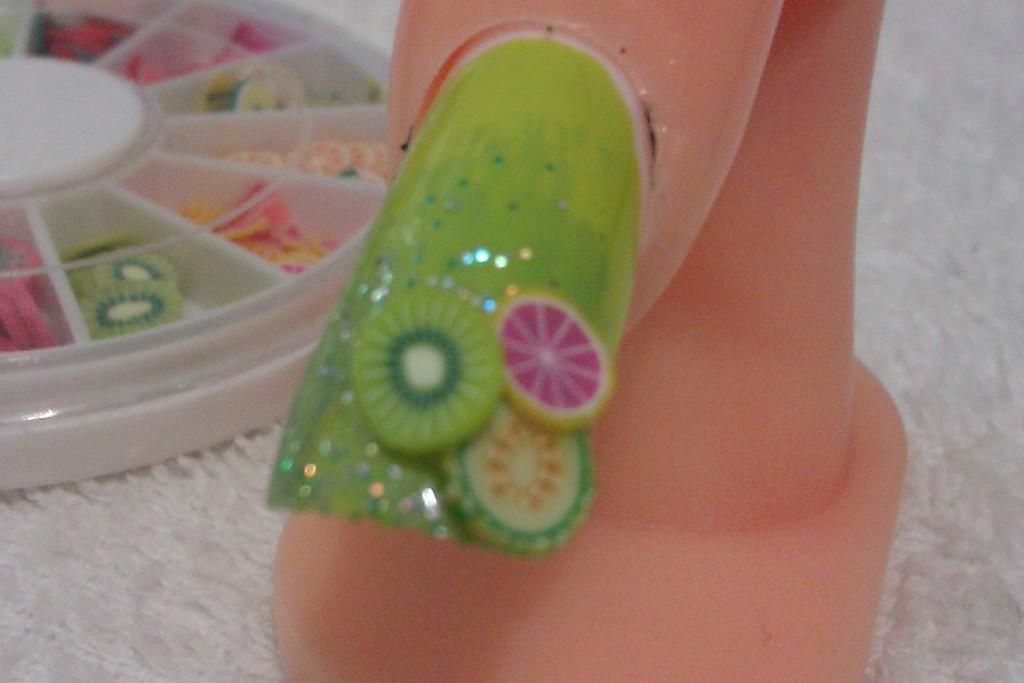What is the main subject of the image? The main subject of the image is an art on a nail of a finger on a stand. Where is the stand located? The stand is on a cloth. What else can be seen in the image related to nail art? There is a box of nail art materials on the left side, and it is also on the cloth. What type of current can be seen flowing through the pot in the image? There is no pot or current present in the image. 